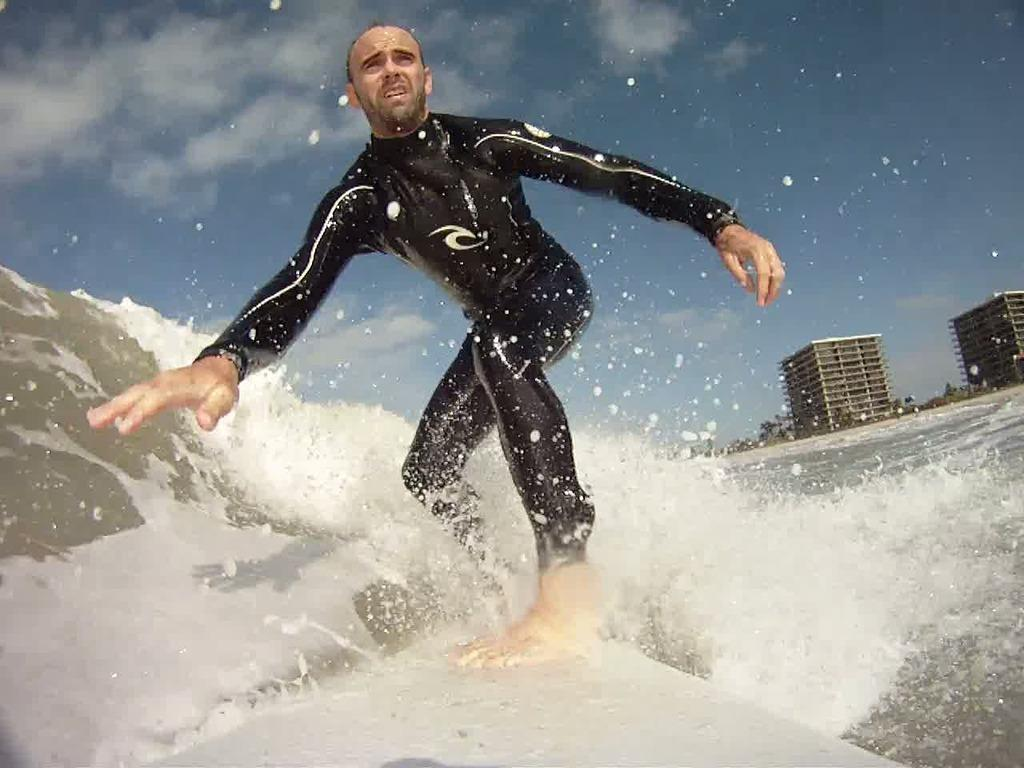What activity is the person in the image engaged in? The person is surfing in the image. What is the person wearing while surfing? The person is wearing a black dress. What can be seen in the background of the image? There is a building in the background of the image. What is the color of the building? The building is white in color. What is visible above the building in the image? The sky is visible in the background of the image. What colors can be seen in the sky? The sky has a blue and white color. What type of record is the person holding while surfing? There is no record present in the image; the person is surfing and wearing a black dress. What type of jeans is the bee wearing while flying in the image? There is no bee present in the image, and bees do not wear jeans. 